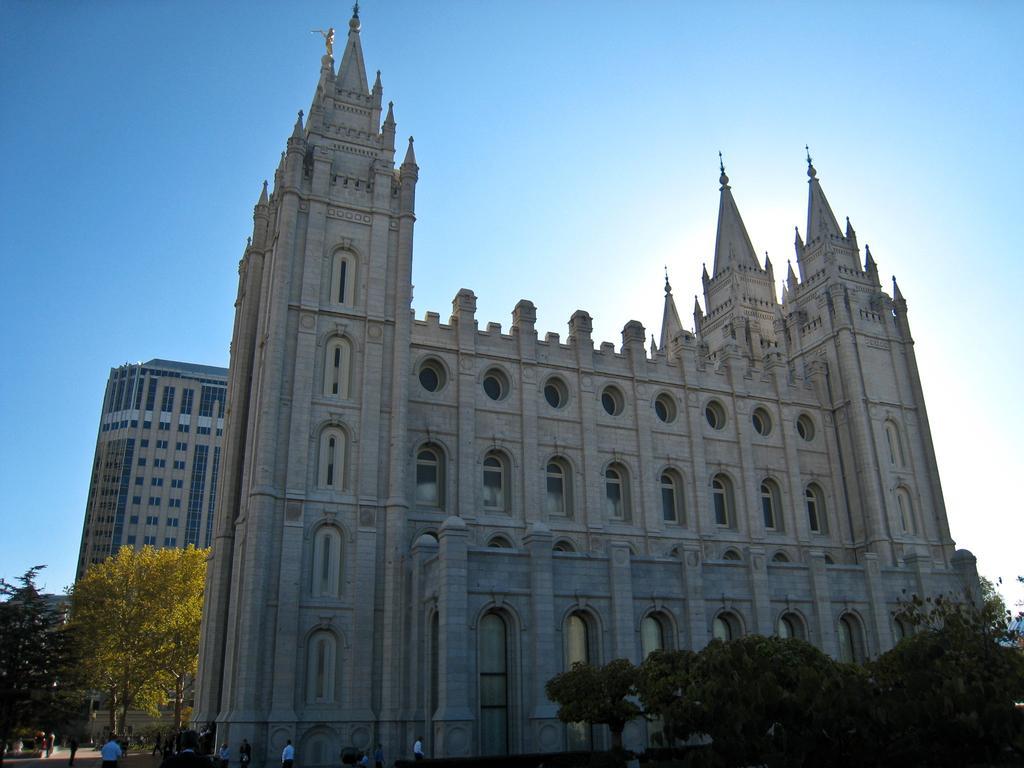Could you give a brief overview of what you see in this image? In the picture there are buildings, there are trees, there are people walking, there is a clear sky. 